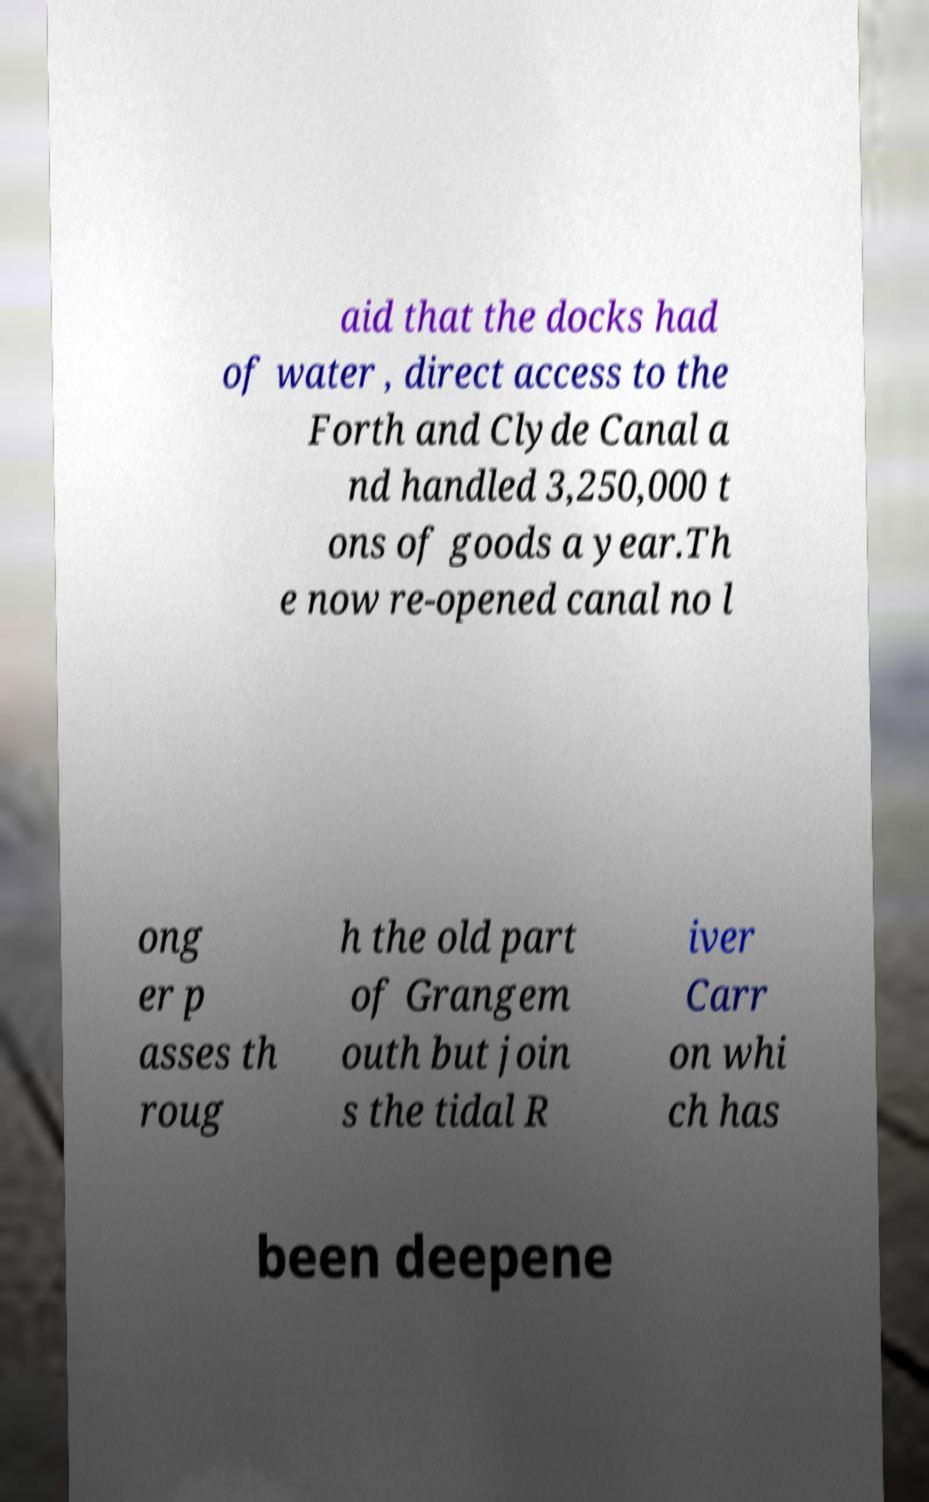Could you extract and type out the text from this image? aid that the docks had of water , direct access to the Forth and Clyde Canal a nd handled 3,250,000 t ons of goods a year.Th e now re-opened canal no l ong er p asses th roug h the old part of Grangem outh but join s the tidal R iver Carr on whi ch has been deepene 